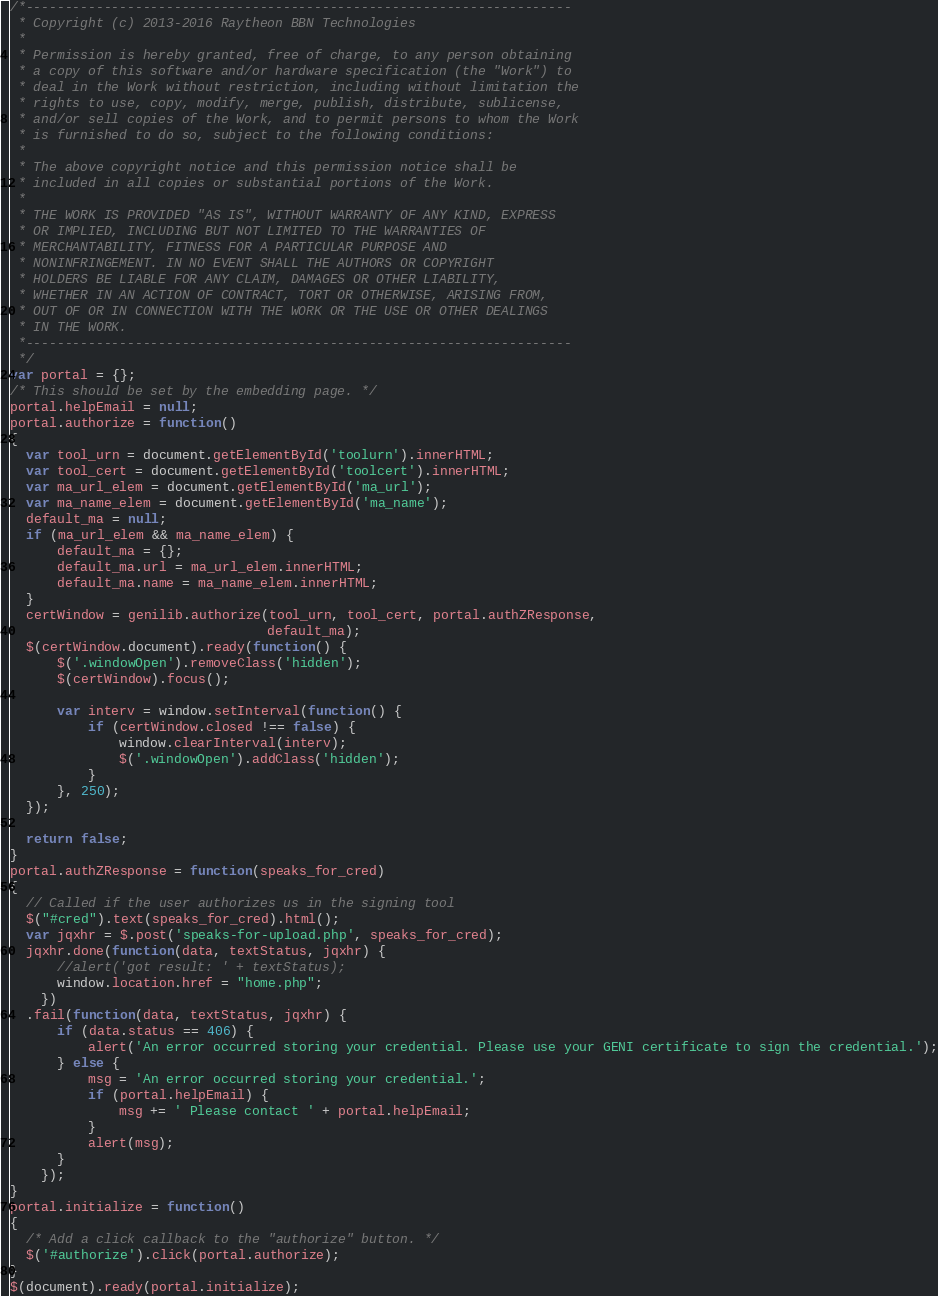<code> <loc_0><loc_0><loc_500><loc_500><_JavaScript_>/*----------------------------------------------------------------------
 * Copyright (c) 2013-2016 Raytheon BBN Technologies
 *
 * Permission is hereby granted, free of charge, to any person obtaining
 * a copy of this software and/or hardware specification (the "Work") to
 * deal in the Work without restriction, including without limitation the
 * rights to use, copy, modify, merge, publish, distribute, sublicense,
 * and/or sell copies of the Work, and to permit persons to whom the Work
 * is furnished to do so, subject to the following conditions:
 *
 * The above copyright notice and this permission notice shall be
 * included in all copies or substantial portions of the Work.
 *
 * THE WORK IS PROVIDED "AS IS", WITHOUT WARRANTY OF ANY KIND, EXPRESS
 * OR IMPLIED, INCLUDING BUT NOT LIMITED TO THE WARRANTIES OF
 * MERCHANTABILITY, FITNESS FOR A PARTICULAR PURPOSE AND
 * NONINFRINGEMENT. IN NO EVENT SHALL THE AUTHORS OR COPYRIGHT
 * HOLDERS BE LIABLE FOR ANY CLAIM, DAMAGES OR OTHER LIABILITY,
 * WHETHER IN AN ACTION OF CONTRACT, TORT OR OTHERWISE, ARISING FROM,
 * OUT OF OR IN CONNECTION WITH THE WORK OR THE USE OR OTHER DEALINGS
 * IN THE WORK.
 *----------------------------------------------------------------------
 */
var portal = {};
/* This should be set by the embedding page. */
portal.helpEmail = null;
portal.authorize = function()
{
  var tool_urn = document.getElementById('toolurn').innerHTML;
  var tool_cert = document.getElementById('toolcert').innerHTML;
  var ma_url_elem = document.getElementById('ma_url');
  var ma_name_elem = document.getElementById('ma_name');
  default_ma = null;
  if (ma_url_elem && ma_name_elem) {
      default_ma = {};
      default_ma.url = ma_url_elem.innerHTML;
      default_ma.name = ma_name_elem.innerHTML;
  }
  certWindow = genilib.authorize(tool_urn, tool_cert, portal.authZResponse,
                                 default_ma);
  $(certWindow.document).ready(function() {
      $('.windowOpen').removeClass('hidden');
      $(certWindow).focus();

      var interv = window.setInterval(function() {
          if (certWindow.closed !== false) {
              window.clearInterval(interv);
              $('.windowOpen').addClass('hidden');
          }
      }, 250);
  });

  return false;
}
portal.authZResponse = function(speaks_for_cred)
{
  // Called if the user authorizes us in the signing tool
  $("#cred").text(speaks_for_cred).html();
  var jqxhr = $.post('speaks-for-upload.php', speaks_for_cred);
  jqxhr.done(function(data, textStatus, jqxhr) {
      //alert('got result: ' + textStatus);
      window.location.href = "home.php";
    })
  .fail(function(data, textStatus, jqxhr) {
      if (data.status == 406) {
          alert('An error occurred storing your credential. Please use your GENI certificate to sign the credential.');
      } else {
          msg = 'An error occurred storing your credential.';
          if (portal.helpEmail) {
              msg += ' Please contact ' + portal.helpEmail;
          }
          alert(msg);
      }
    });
}
portal.initialize = function()
{
  /* Add a click callback to the "authorize" button. */
  $('#authorize').click(portal.authorize);
}
$(document).ready(portal.initialize);
</code> 